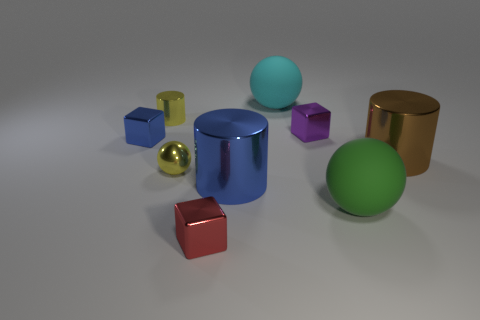What shape is the blue metal object that is the same size as the red object?
Provide a succinct answer. Cube. How many tiny shiny blocks are left of the large metal object left of the cylinder that is right of the cyan sphere?
Your answer should be very brief. 2. How many metal objects are either small purple objects or large blue objects?
Offer a terse response. 2. There is a tiny block that is right of the yellow metallic cylinder and on the left side of the big cyan rubber ball; what is its color?
Give a very brief answer. Red. There is a yellow metal thing that is in front of the blue metallic cube; is its size the same as the red metallic object?
Ensure brevity in your answer.  Yes. How many objects are either large rubber balls behind the big green object or yellow metal spheres?
Provide a short and direct response. 2. Are there any brown rubber blocks that have the same size as the brown shiny cylinder?
Ensure brevity in your answer.  No. There is another sphere that is the same size as the green ball; what is its material?
Provide a short and direct response. Rubber. There is a thing that is to the right of the blue metallic cylinder and behind the purple metal object; what shape is it?
Ensure brevity in your answer.  Sphere. There is a big object that is behind the yellow shiny cylinder; what is its color?
Offer a terse response. Cyan. 